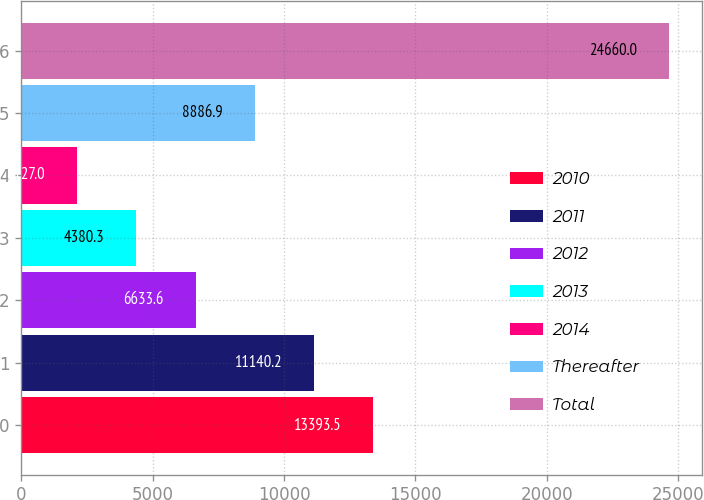Convert chart to OTSL. <chart><loc_0><loc_0><loc_500><loc_500><bar_chart><fcel>2010<fcel>2011<fcel>2012<fcel>2013<fcel>2014<fcel>Thereafter<fcel>Total<nl><fcel>13393.5<fcel>11140.2<fcel>6633.6<fcel>4380.3<fcel>2127<fcel>8886.9<fcel>24660<nl></chart> 